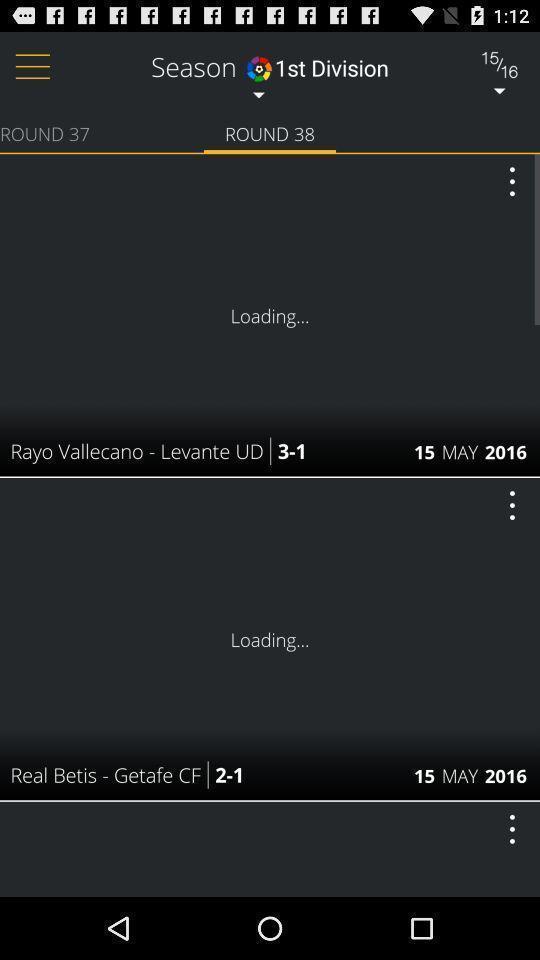Provide a textual representation of this image. Screen shows live news of a country 's sports app. 